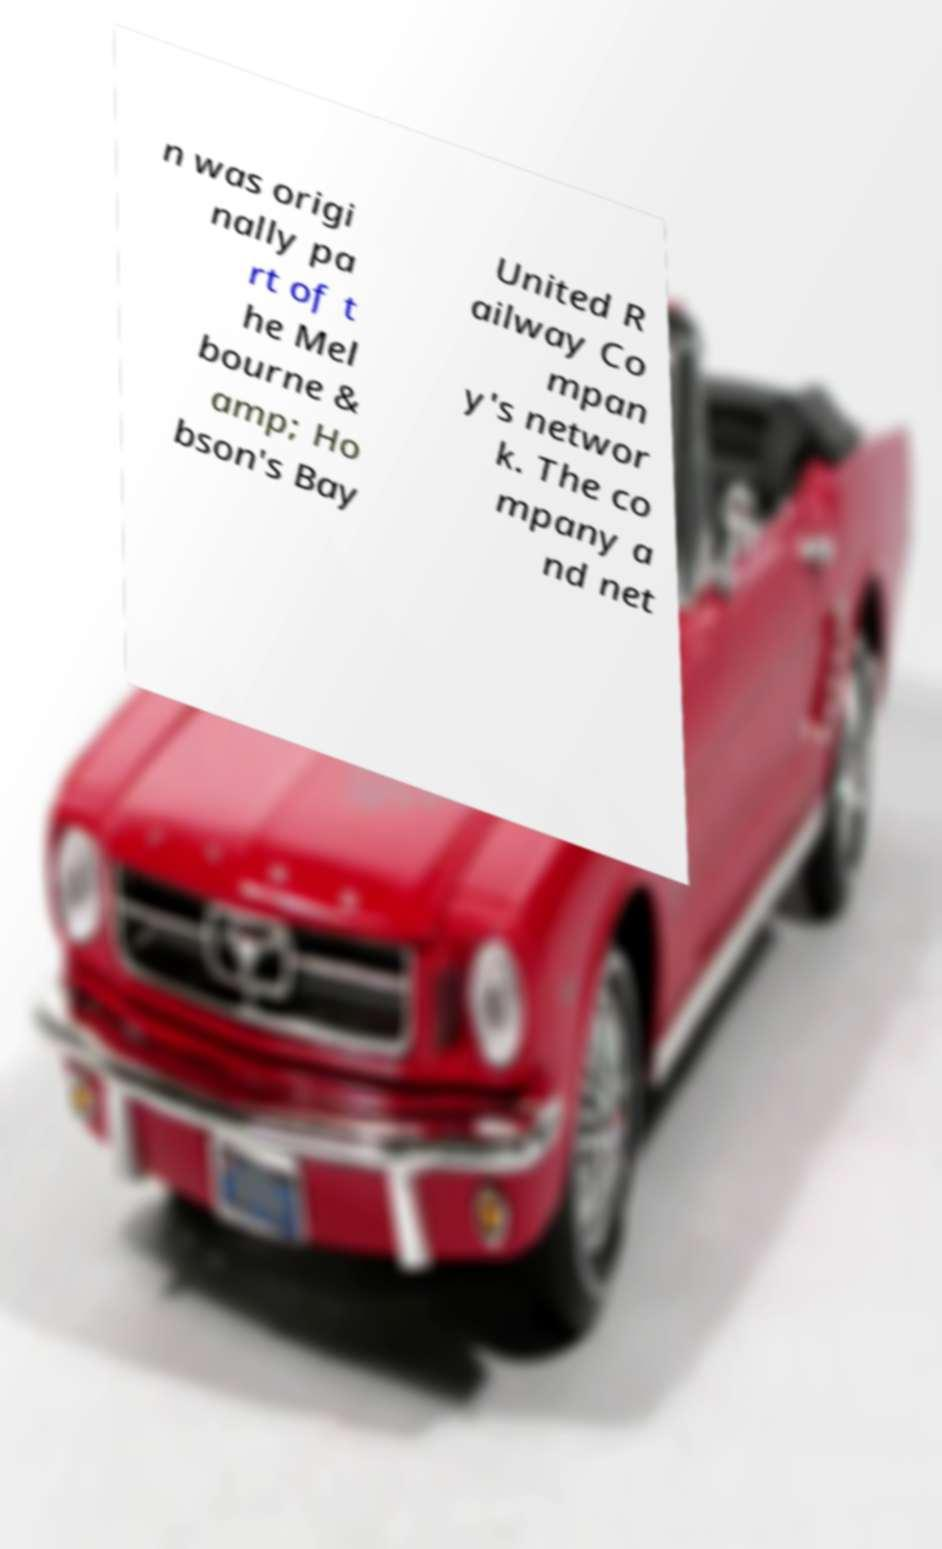I need the written content from this picture converted into text. Can you do that? n was origi nally pa rt of t he Mel bourne & amp; Ho bson's Bay United R ailway Co mpan y's networ k. The co mpany a nd net 